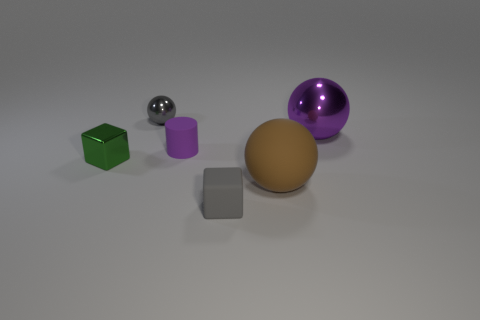What is the material of the small thing that is the same color as the large shiny thing?
Offer a very short reply. Rubber. Is there a green shiny object that has the same size as the purple sphere?
Ensure brevity in your answer.  No. What number of things are metallic things that are on the left side of the tiny purple thing or shiny things on the right side of the gray metallic sphere?
Offer a terse response. 3. The green metal thing that is the same size as the gray metal object is what shape?
Offer a terse response. Cube. Is there another matte thing that has the same shape as the small green thing?
Provide a short and direct response. Yes. Is the number of big brown balls less than the number of shiny spheres?
Keep it short and to the point. Yes. There is a cube on the left side of the tiny purple cylinder; is its size the same as the cube that is in front of the small green shiny thing?
Give a very brief answer. Yes. What number of things are either tiny rubber objects or spheres?
Offer a terse response. 5. What size is the gray block in front of the big rubber object?
Ensure brevity in your answer.  Small. There is a ball that is to the left of the block that is in front of the green block; how many tiny purple rubber cylinders are left of it?
Give a very brief answer. 0. 